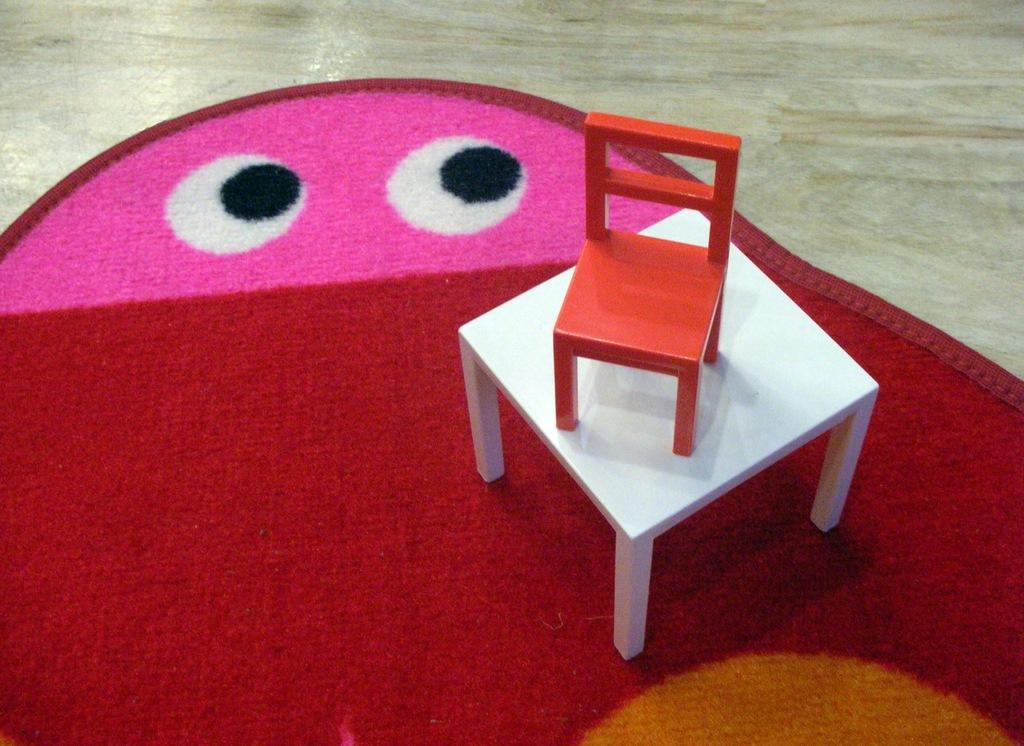What type of floor covering is visible in the image? There is a carpet on the floor. What furniture is placed on the carpet? There is a table and a chair on the carpet. What type of magic is being performed on the carpet in the image? There is no magic or any indication of a magical event happening in the image. 